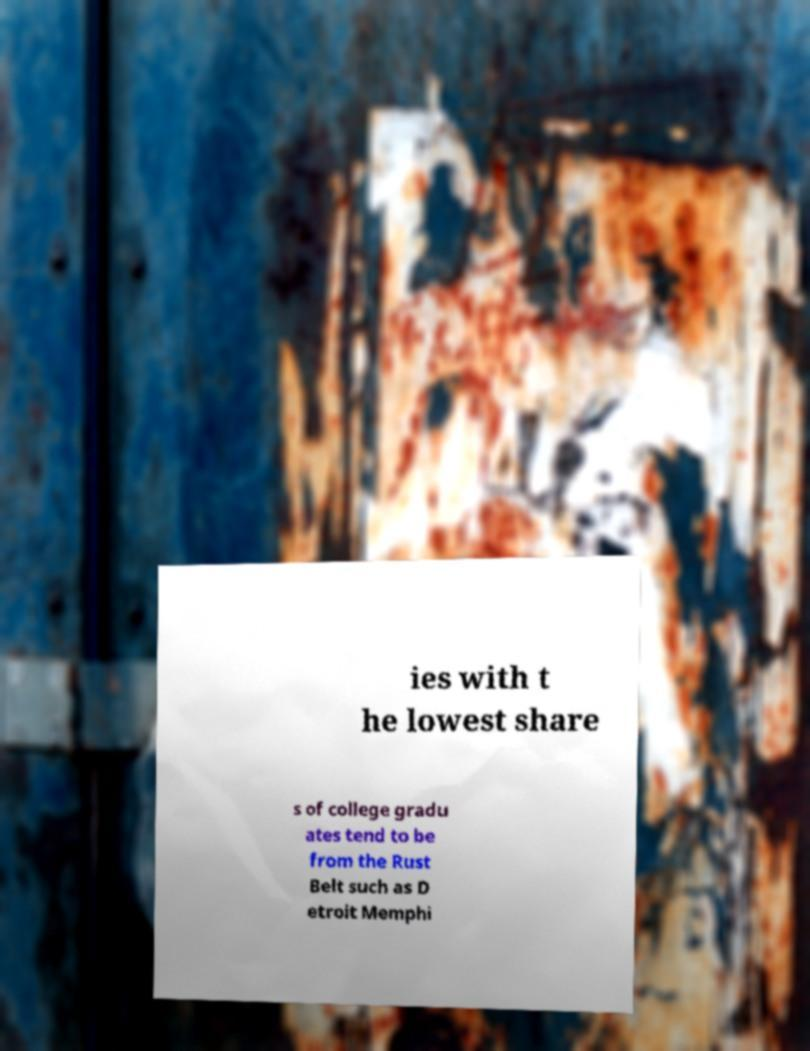I need the written content from this picture converted into text. Can you do that? ies with t he lowest share s of college gradu ates tend to be from the Rust Belt such as D etroit Memphi 